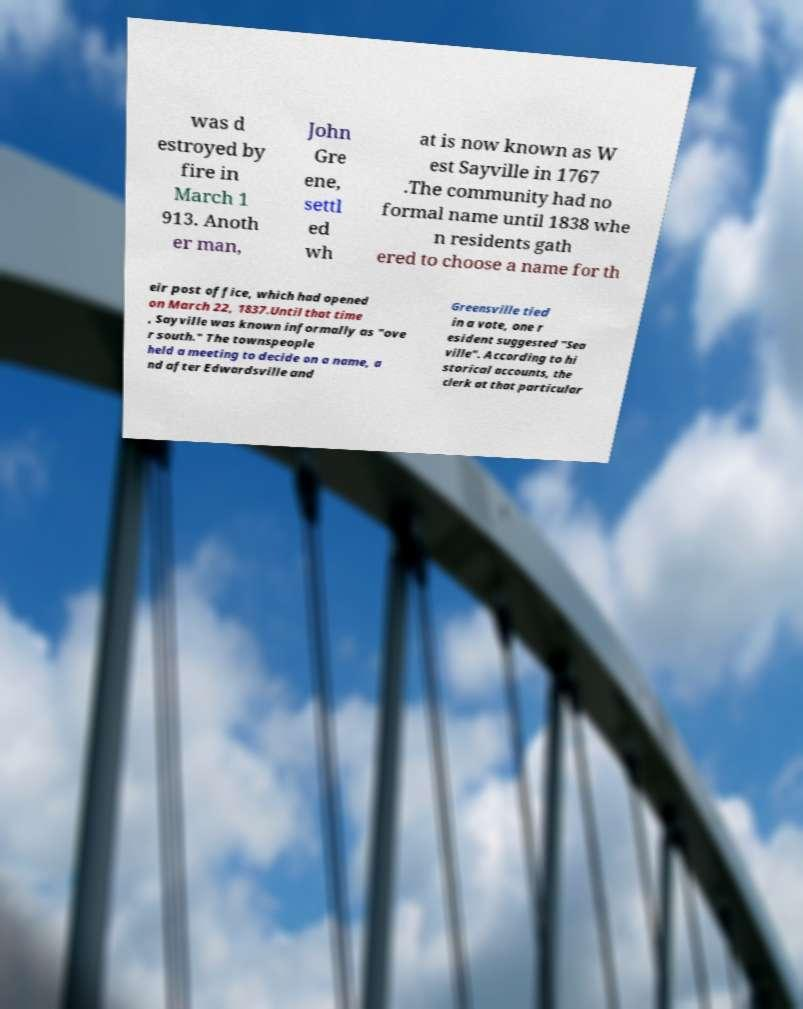Could you extract and type out the text from this image? was d estroyed by fire in March 1 913. Anoth er man, John Gre ene, settl ed wh at is now known as W est Sayville in 1767 .The community had no formal name until 1838 whe n residents gath ered to choose a name for th eir post office, which had opened on March 22, 1837.Until that time , Sayville was known informally as "ove r south." The townspeople held a meeting to decide on a name, a nd after Edwardsville and Greensville tied in a vote, one r esident suggested "Sea ville". According to hi storical accounts, the clerk at that particular 